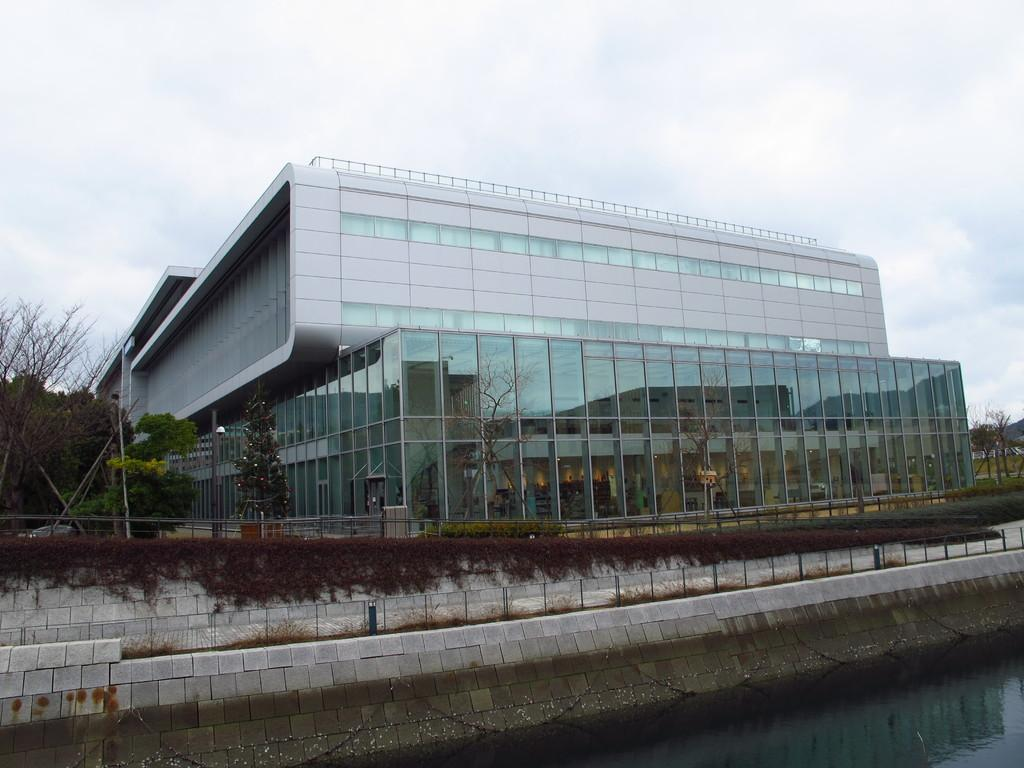What type of structure is present in the image? There is a building in the image. What natural elements can be seen in the image? There is a group of trees and plants in the image. What man-made objects are visible in the image? There are poles and a chain in the image. What type of landscape feature is present in the image? There is a water body in the image. What is the condition of the sky in the image? The sky is visible in the image and appears cloudy. How many giants can be seen walking near the water body in the image? There are no giants present in the image; it features a building, trees, plants, poles, a chain, a water body, and a cloudy sky. What type of pen is used to draw the chain in the image? There is no pen present in the image; it is a photograph or digital representation of a real-world scene. 